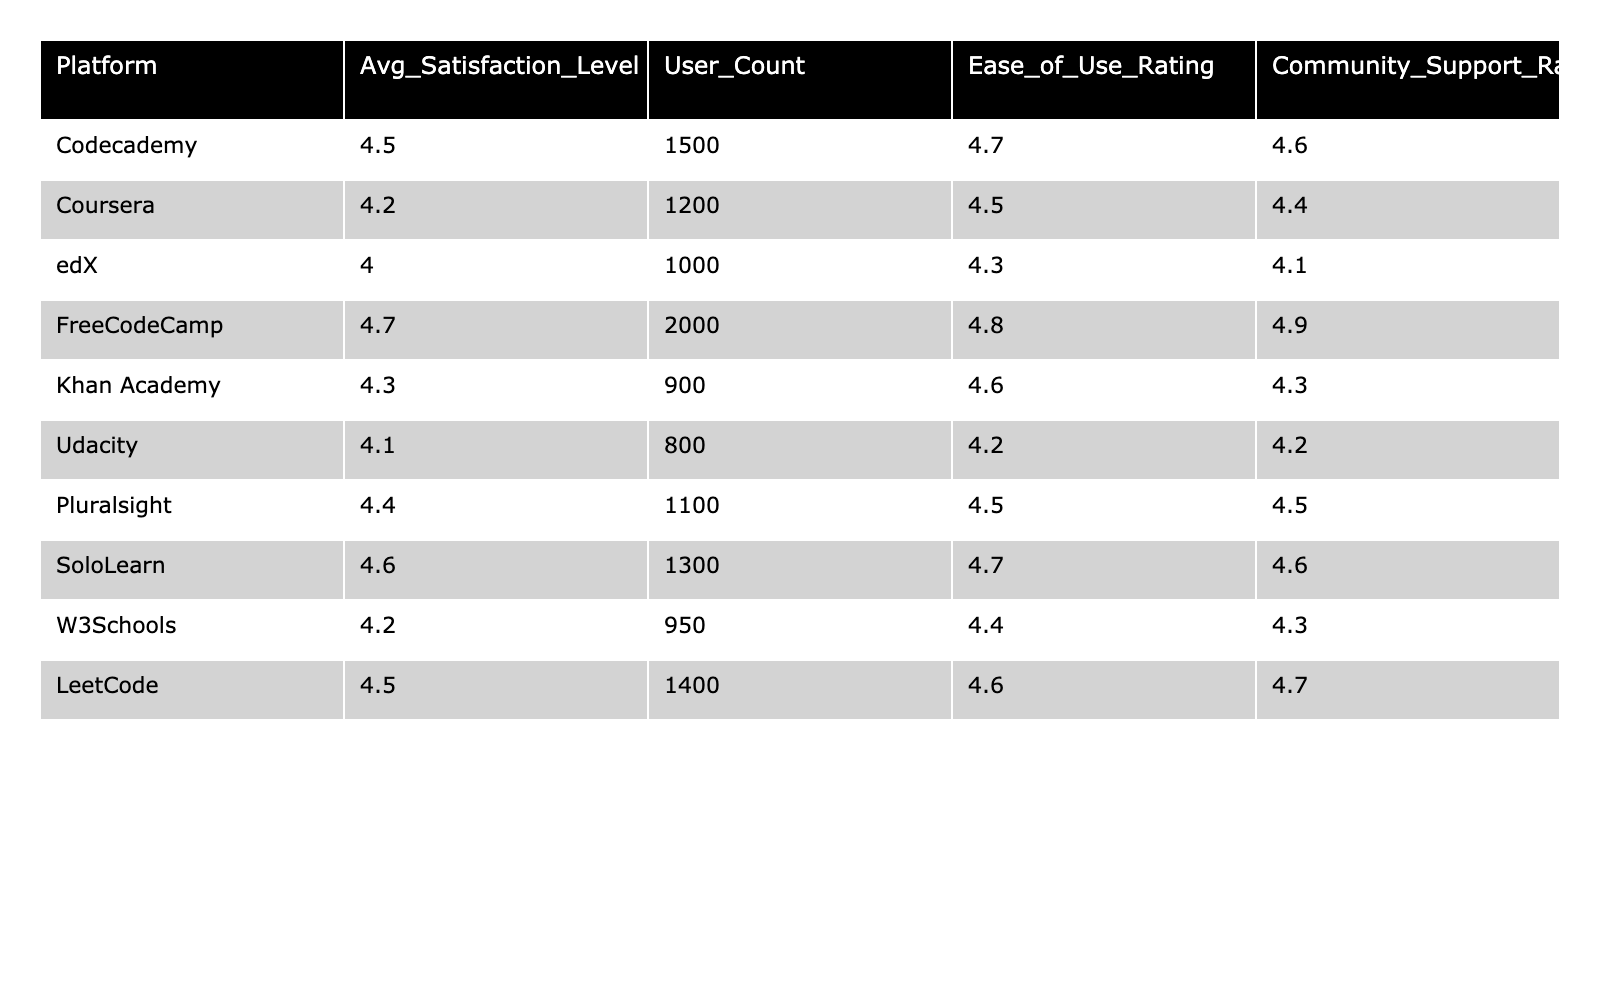What is the average satisfaction level of FreeCodeCamp users? The table shows that the average satisfaction level for FreeCodeCamp is 4.7.
Answer: 4.7 Which platform has the highest community support rating? Reviewing the community support ratings, FreeCodeCamp has the highest rating at 4.9.
Answer: FreeCodeCamp What is the average ease of use rating for all platforms combined? To find the average, sum the ease of use ratings (4.7 + 4.5 + 4.3 + 4.8 + 4.6 + 4.2 + 4.5 + 4.7 + 4.4 + 4.6 = 44.3) and divide by the number of platforms (10), giving 44.3/10 = 4.43.
Answer: 4.43 Is the average satisfaction level for Udacity greater than or equal to 4.2? Udacity's average satisfaction level is 4.1, which is less than 4.2.
Answer: No What is the difference in average satisfaction levels between FreeCodeCamp and edX? FreeCodeCamp’s average is 4.7, and edX’s is 4.0. The difference is 4.7 - 4.0 = 0.7.
Answer: 0.7 How many platforms have an average satisfaction level above 4.4? The platforms with satisfaction levels above 4.4 are Codecademy, FreeCodeCamp, SoloLearn, and LeetCode, totaling four platforms.
Answer: 4 Which platforms have an average rating below the average satisfaction level of 4.2, and what is their count? The platforms below 4.2 average are edX (4.0), Udacity (4.1), total two platforms are under that threshold.
Answer: 2 What is the total user count for all platforms listed? The total user count is calculated by summing individual user counts: (1500 + 1200 + 1000 + 2000 + 900 + 800 + 1100 + 1300 + 950 + 1400 = 13,150).
Answer: 13150 Which platform has the lowest ease of use rating and what is its value? The lowest ease of use rating is from Udacity, with a rating of 4.2.
Answer: 4.2 Is the average satisfaction level for Codecademy greater than that of Udacity? Codecademy’s average is 4.5, and Udacity’s is 4.1, thus Codecademy is greater.
Answer: Yes 